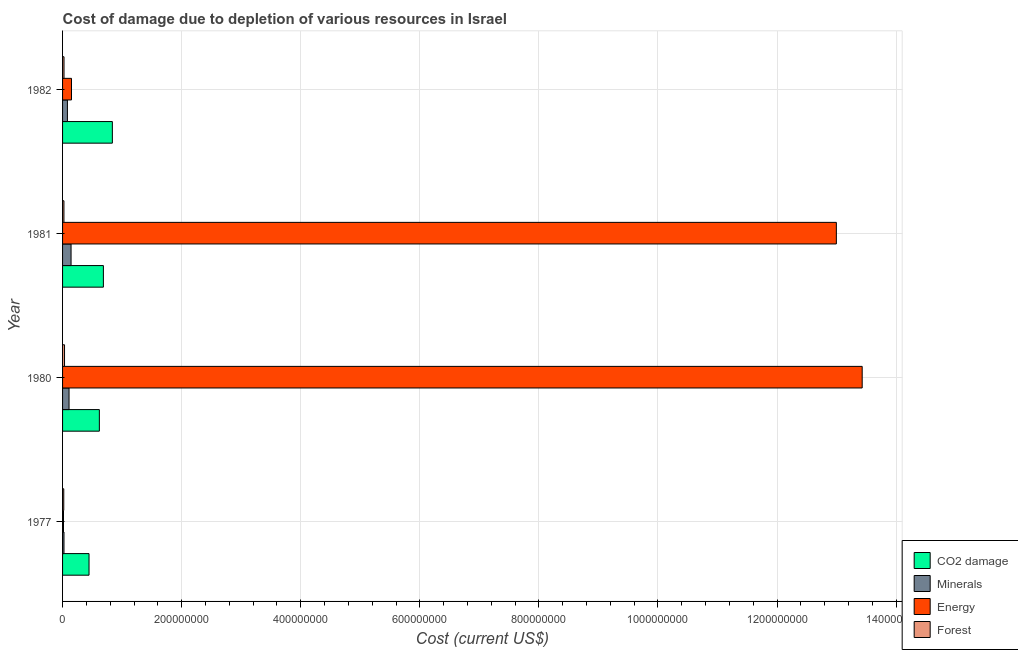Are the number of bars on each tick of the Y-axis equal?
Provide a succinct answer. Yes. How many bars are there on the 2nd tick from the top?
Your response must be concise. 4. What is the label of the 1st group of bars from the top?
Offer a very short reply. 1982. What is the cost of damage due to depletion of forests in 1981?
Your answer should be compact. 2.30e+06. Across all years, what is the maximum cost of damage due to depletion of energy?
Your answer should be compact. 1.34e+09. Across all years, what is the minimum cost of damage due to depletion of energy?
Your response must be concise. 1.57e+06. What is the total cost of damage due to depletion of energy in the graph?
Your answer should be compact. 2.66e+09. What is the difference between the cost of damage due to depletion of forests in 1977 and that in 1981?
Offer a very short reply. -3.02e+05. What is the difference between the cost of damage due to depletion of minerals in 1981 and the cost of damage due to depletion of forests in 1980?
Provide a succinct answer. 1.10e+07. What is the average cost of damage due to depletion of minerals per year?
Your answer should be very brief. 8.92e+06. In the year 1980, what is the difference between the cost of damage due to depletion of energy and cost of damage due to depletion of minerals?
Offer a terse response. 1.33e+09. In how many years, is the cost of damage due to depletion of forests greater than 1360000000 US$?
Your answer should be compact. 0. What is the ratio of the cost of damage due to depletion of forests in 1977 to that in 1982?
Keep it short and to the point. 0.82. Is the cost of damage due to depletion of forests in 1977 less than that in 1981?
Your answer should be very brief. Yes. What is the difference between the highest and the second highest cost of damage due to depletion of forests?
Offer a terse response. 8.64e+05. What is the difference between the highest and the lowest cost of damage due to depletion of forests?
Give a very brief answer. 1.29e+06. In how many years, is the cost of damage due to depletion of energy greater than the average cost of damage due to depletion of energy taken over all years?
Provide a succinct answer. 2. Is the sum of the cost of damage due to depletion of coal in 1977 and 1982 greater than the maximum cost of damage due to depletion of energy across all years?
Offer a very short reply. No. Is it the case that in every year, the sum of the cost of damage due to depletion of forests and cost of damage due to depletion of energy is greater than the sum of cost of damage due to depletion of minerals and cost of damage due to depletion of coal?
Offer a terse response. No. What does the 4th bar from the top in 1982 represents?
Your response must be concise. CO2 damage. What does the 3rd bar from the bottom in 1977 represents?
Provide a succinct answer. Energy. Is it the case that in every year, the sum of the cost of damage due to depletion of coal and cost of damage due to depletion of minerals is greater than the cost of damage due to depletion of energy?
Give a very brief answer. No. How many years are there in the graph?
Provide a short and direct response. 4. What is the difference between two consecutive major ticks on the X-axis?
Ensure brevity in your answer.  2.00e+08. Are the values on the major ticks of X-axis written in scientific E-notation?
Your answer should be very brief. No. Does the graph contain grids?
Keep it short and to the point. Yes. How are the legend labels stacked?
Your response must be concise. Vertical. What is the title of the graph?
Your response must be concise. Cost of damage due to depletion of various resources in Israel . Does "Agricultural land" appear as one of the legend labels in the graph?
Offer a very short reply. No. What is the label or title of the X-axis?
Ensure brevity in your answer.  Cost (current US$). What is the Cost (current US$) in CO2 damage in 1977?
Ensure brevity in your answer.  4.44e+07. What is the Cost (current US$) of Minerals in 1977?
Give a very brief answer. 2.37e+06. What is the Cost (current US$) in Energy in 1977?
Provide a short and direct response. 1.57e+06. What is the Cost (current US$) in Forest in 1977?
Ensure brevity in your answer.  2.00e+06. What is the Cost (current US$) in CO2 damage in 1980?
Make the answer very short. 6.18e+07. What is the Cost (current US$) in Minerals in 1980?
Offer a very short reply. 1.09e+07. What is the Cost (current US$) of Energy in 1980?
Your answer should be compact. 1.34e+09. What is the Cost (current US$) in Forest in 1980?
Ensure brevity in your answer.  3.30e+06. What is the Cost (current US$) of CO2 damage in 1981?
Make the answer very short. 6.86e+07. What is the Cost (current US$) of Minerals in 1981?
Your answer should be compact. 1.43e+07. What is the Cost (current US$) of Energy in 1981?
Make the answer very short. 1.30e+09. What is the Cost (current US$) in Forest in 1981?
Make the answer very short. 2.30e+06. What is the Cost (current US$) in CO2 damage in 1982?
Offer a very short reply. 8.36e+07. What is the Cost (current US$) of Minerals in 1982?
Provide a succinct answer. 8.15e+06. What is the Cost (current US$) in Energy in 1982?
Your answer should be very brief. 1.50e+07. What is the Cost (current US$) of Forest in 1982?
Your response must be concise. 2.43e+06. Across all years, what is the maximum Cost (current US$) of CO2 damage?
Ensure brevity in your answer.  8.36e+07. Across all years, what is the maximum Cost (current US$) of Minerals?
Offer a very short reply. 1.43e+07. Across all years, what is the maximum Cost (current US$) in Energy?
Your answer should be very brief. 1.34e+09. Across all years, what is the maximum Cost (current US$) of Forest?
Your response must be concise. 3.30e+06. Across all years, what is the minimum Cost (current US$) of CO2 damage?
Provide a succinct answer. 4.44e+07. Across all years, what is the minimum Cost (current US$) in Minerals?
Keep it short and to the point. 2.37e+06. Across all years, what is the minimum Cost (current US$) in Energy?
Your answer should be very brief. 1.57e+06. Across all years, what is the minimum Cost (current US$) of Forest?
Your response must be concise. 2.00e+06. What is the total Cost (current US$) of CO2 damage in the graph?
Ensure brevity in your answer.  2.58e+08. What is the total Cost (current US$) of Minerals in the graph?
Keep it short and to the point. 3.57e+07. What is the total Cost (current US$) of Energy in the graph?
Your response must be concise. 2.66e+09. What is the total Cost (current US$) in Forest in the graph?
Give a very brief answer. 1.00e+07. What is the difference between the Cost (current US$) in CO2 damage in 1977 and that in 1980?
Your answer should be very brief. -1.74e+07. What is the difference between the Cost (current US$) in Minerals in 1977 and that in 1980?
Keep it short and to the point. -8.52e+06. What is the difference between the Cost (current US$) of Energy in 1977 and that in 1980?
Your response must be concise. -1.34e+09. What is the difference between the Cost (current US$) in Forest in 1977 and that in 1980?
Give a very brief answer. -1.29e+06. What is the difference between the Cost (current US$) in CO2 damage in 1977 and that in 1981?
Your response must be concise. -2.41e+07. What is the difference between the Cost (current US$) in Minerals in 1977 and that in 1981?
Offer a terse response. -1.19e+07. What is the difference between the Cost (current US$) in Energy in 1977 and that in 1981?
Provide a short and direct response. -1.30e+09. What is the difference between the Cost (current US$) in Forest in 1977 and that in 1981?
Offer a terse response. -3.02e+05. What is the difference between the Cost (current US$) in CO2 damage in 1977 and that in 1982?
Offer a terse response. -3.92e+07. What is the difference between the Cost (current US$) of Minerals in 1977 and that in 1982?
Offer a very short reply. -5.78e+06. What is the difference between the Cost (current US$) in Energy in 1977 and that in 1982?
Your answer should be compact. -1.34e+07. What is the difference between the Cost (current US$) of Forest in 1977 and that in 1982?
Offer a terse response. -4.31e+05. What is the difference between the Cost (current US$) of CO2 damage in 1980 and that in 1981?
Your answer should be very brief. -6.78e+06. What is the difference between the Cost (current US$) in Minerals in 1980 and that in 1981?
Your answer should be compact. -3.38e+06. What is the difference between the Cost (current US$) in Energy in 1980 and that in 1981?
Offer a terse response. 4.34e+07. What is the difference between the Cost (current US$) in Forest in 1980 and that in 1981?
Offer a very short reply. 9.93e+05. What is the difference between the Cost (current US$) in CO2 damage in 1980 and that in 1982?
Ensure brevity in your answer.  -2.18e+07. What is the difference between the Cost (current US$) of Minerals in 1980 and that in 1982?
Provide a short and direct response. 2.74e+06. What is the difference between the Cost (current US$) of Energy in 1980 and that in 1982?
Your answer should be very brief. 1.33e+09. What is the difference between the Cost (current US$) in Forest in 1980 and that in 1982?
Offer a terse response. 8.64e+05. What is the difference between the Cost (current US$) of CO2 damage in 1981 and that in 1982?
Offer a very short reply. -1.51e+07. What is the difference between the Cost (current US$) in Minerals in 1981 and that in 1982?
Offer a very short reply. 6.13e+06. What is the difference between the Cost (current US$) in Energy in 1981 and that in 1982?
Offer a terse response. 1.28e+09. What is the difference between the Cost (current US$) in Forest in 1981 and that in 1982?
Your response must be concise. -1.29e+05. What is the difference between the Cost (current US$) in CO2 damage in 1977 and the Cost (current US$) in Minerals in 1980?
Make the answer very short. 3.35e+07. What is the difference between the Cost (current US$) of CO2 damage in 1977 and the Cost (current US$) of Energy in 1980?
Provide a succinct answer. -1.30e+09. What is the difference between the Cost (current US$) of CO2 damage in 1977 and the Cost (current US$) of Forest in 1980?
Make the answer very short. 4.11e+07. What is the difference between the Cost (current US$) in Minerals in 1977 and the Cost (current US$) in Energy in 1980?
Offer a very short reply. -1.34e+09. What is the difference between the Cost (current US$) in Minerals in 1977 and the Cost (current US$) in Forest in 1980?
Your answer should be compact. -9.28e+05. What is the difference between the Cost (current US$) of Energy in 1977 and the Cost (current US$) of Forest in 1980?
Provide a succinct answer. -1.73e+06. What is the difference between the Cost (current US$) of CO2 damage in 1977 and the Cost (current US$) of Minerals in 1981?
Your answer should be very brief. 3.02e+07. What is the difference between the Cost (current US$) of CO2 damage in 1977 and the Cost (current US$) of Energy in 1981?
Offer a very short reply. -1.26e+09. What is the difference between the Cost (current US$) in CO2 damage in 1977 and the Cost (current US$) in Forest in 1981?
Ensure brevity in your answer.  4.21e+07. What is the difference between the Cost (current US$) in Minerals in 1977 and the Cost (current US$) in Energy in 1981?
Your answer should be very brief. -1.30e+09. What is the difference between the Cost (current US$) in Minerals in 1977 and the Cost (current US$) in Forest in 1981?
Offer a terse response. 6.51e+04. What is the difference between the Cost (current US$) of Energy in 1977 and the Cost (current US$) of Forest in 1981?
Provide a succinct answer. -7.37e+05. What is the difference between the Cost (current US$) in CO2 damage in 1977 and the Cost (current US$) in Minerals in 1982?
Your answer should be very brief. 3.63e+07. What is the difference between the Cost (current US$) in CO2 damage in 1977 and the Cost (current US$) in Energy in 1982?
Provide a succinct answer. 2.94e+07. What is the difference between the Cost (current US$) of CO2 damage in 1977 and the Cost (current US$) of Forest in 1982?
Your response must be concise. 4.20e+07. What is the difference between the Cost (current US$) in Minerals in 1977 and the Cost (current US$) in Energy in 1982?
Keep it short and to the point. -1.26e+07. What is the difference between the Cost (current US$) of Minerals in 1977 and the Cost (current US$) of Forest in 1982?
Make the answer very short. -6.43e+04. What is the difference between the Cost (current US$) in Energy in 1977 and the Cost (current US$) in Forest in 1982?
Keep it short and to the point. -8.67e+05. What is the difference between the Cost (current US$) of CO2 damage in 1980 and the Cost (current US$) of Minerals in 1981?
Keep it short and to the point. 4.75e+07. What is the difference between the Cost (current US$) of CO2 damage in 1980 and the Cost (current US$) of Energy in 1981?
Your response must be concise. -1.24e+09. What is the difference between the Cost (current US$) of CO2 damage in 1980 and the Cost (current US$) of Forest in 1981?
Your answer should be compact. 5.95e+07. What is the difference between the Cost (current US$) in Minerals in 1980 and the Cost (current US$) in Energy in 1981?
Make the answer very short. -1.29e+09. What is the difference between the Cost (current US$) of Minerals in 1980 and the Cost (current US$) of Forest in 1981?
Offer a terse response. 8.58e+06. What is the difference between the Cost (current US$) in Energy in 1980 and the Cost (current US$) in Forest in 1981?
Provide a succinct answer. 1.34e+09. What is the difference between the Cost (current US$) of CO2 damage in 1980 and the Cost (current US$) of Minerals in 1982?
Your answer should be very brief. 5.36e+07. What is the difference between the Cost (current US$) of CO2 damage in 1980 and the Cost (current US$) of Energy in 1982?
Your response must be concise. 4.68e+07. What is the difference between the Cost (current US$) of CO2 damage in 1980 and the Cost (current US$) of Forest in 1982?
Provide a succinct answer. 5.94e+07. What is the difference between the Cost (current US$) of Minerals in 1980 and the Cost (current US$) of Energy in 1982?
Make the answer very short. -4.13e+06. What is the difference between the Cost (current US$) of Minerals in 1980 and the Cost (current US$) of Forest in 1982?
Offer a very short reply. 8.45e+06. What is the difference between the Cost (current US$) in Energy in 1980 and the Cost (current US$) in Forest in 1982?
Ensure brevity in your answer.  1.34e+09. What is the difference between the Cost (current US$) of CO2 damage in 1981 and the Cost (current US$) of Minerals in 1982?
Provide a succinct answer. 6.04e+07. What is the difference between the Cost (current US$) in CO2 damage in 1981 and the Cost (current US$) in Energy in 1982?
Your answer should be very brief. 5.36e+07. What is the difference between the Cost (current US$) in CO2 damage in 1981 and the Cost (current US$) in Forest in 1982?
Offer a very short reply. 6.61e+07. What is the difference between the Cost (current US$) of Minerals in 1981 and the Cost (current US$) of Energy in 1982?
Your answer should be very brief. -7.43e+05. What is the difference between the Cost (current US$) in Minerals in 1981 and the Cost (current US$) in Forest in 1982?
Provide a succinct answer. 1.18e+07. What is the difference between the Cost (current US$) in Energy in 1981 and the Cost (current US$) in Forest in 1982?
Make the answer very short. 1.30e+09. What is the average Cost (current US$) in CO2 damage per year?
Your answer should be very brief. 6.46e+07. What is the average Cost (current US$) in Minerals per year?
Provide a succinct answer. 8.92e+06. What is the average Cost (current US$) of Energy per year?
Keep it short and to the point. 6.65e+08. What is the average Cost (current US$) of Forest per year?
Your response must be concise. 2.51e+06. In the year 1977, what is the difference between the Cost (current US$) in CO2 damage and Cost (current US$) in Minerals?
Your answer should be very brief. 4.21e+07. In the year 1977, what is the difference between the Cost (current US$) of CO2 damage and Cost (current US$) of Energy?
Offer a very short reply. 4.29e+07. In the year 1977, what is the difference between the Cost (current US$) in CO2 damage and Cost (current US$) in Forest?
Make the answer very short. 4.24e+07. In the year 1977, what is the difference between the Cost (current US$) of Minerals and Cost (current US$) of Energy?
Your answer should be very brief. 8.03e+05. In the year 1977, what is the difference between the Cost (current US$) of Minerals and Cost (current US$) of Forest?
Your answer should be compact. 3.67e+05. In the year 1977, what is the difference between the Cost (current US$) of Energy and Cost (current US$) of Forest?
Provide a succinct answer. -4.36e+05. In the year 1980, what is the difference between the Cost (current US$) in CO2 damage and Cost (current US$) in Minerals?
Keep it short and to the point. 5.09e+07. In the year 1980, what is the difference between the Cost (current US$) in CO2 damage and Cost (current US$) in Energy?
Offer a terse response. -1.28e+09. In the year 1980, what is the difference between the Cost (current US$) of CO2 damage and Cost (current US$) of Forest?
Keep it short and to the point. 5.85e+07. In the year 1980, what is the difference between the Cost (current US$) of Minerals and Cost (current US$) of Energy?
Your answer should be very brief. -1.33e+09. In the year 1980, what is the difference between the Cost (current US$) of Minerals and Cost (current US$) of Forest?
Ensure brevity in your answer.  7.59e+06. In the year 1980, what is the difference between the Cost (current US$) of Energy and Cost (current US$) of Forest?
Provide a succinct answer. 1.34e+09. In the year 1981, what is the difference between the Cost (current US$) in CO2 damage and Cost (current US$) in Minerals?
Your answer should be very brief. 5.43e+07. In the year 1981, what is the difference between the Cost (current US$) in CO2 damage and Cost (current US$) in Energy?
Your response must be concise. -1.23e+09. In the year 1981, what is the difference between the Cost (current US$) of CO2 damage and Cost (current US$) of Forest?
Offer a terse response. 6.63e+07. In the year 1981, what is the difference between the Cost (current US$) in Minerals and Cost (current US$) in Energy?
Your answer should be compact. -1.29e+09. In the year 1981, what is the difference between the Cost (current US$) in Minerals and Cost (current US$) in Forest?
Your response must be concise. 1.20e+07. In the year 1981, what is the difference between the Cost (current US$) of Energy and Cost (current US$) of Forest?
Make the answer very short. 1.30e+09. In the year 1982, what is the difference between the Cost (current US$) in CO2 damage and Cost (current US$) in Minerals?
Offer a very short reply. 7.55e+07. In the year 1982, what is the difference between the Cost (current US$) in CO2 damage and Cost (current US$) in Energy?
Provide a short and direct response. 6.86e+07. In the year 1982, what is the difference between the Cost (current US$) in CO2 damage and Cost (current US$) in Forest?
Your response must be concise. 8.12e+07. In the year 1982, what is the difference between the Cost (current US$) in Minerals and Cost (current US$) in Energy?
Provide a short and direct response. -6.87e+06. In the year 1982, what is the difference between the Cost (current US$) of Minerals and Cost (current US$) of Forest?
Keep it short and to the point. 5.71e+06. In the year 1982, what is the difference between the Cost (current US$) of Energy and Cost (current US$) of Forest?
Your answer should be very brief. 1.26e+07. What is the ratio of the Cost (current US$) of CO2 damage in 1977 to that in 1980?
Your answer should be compact. 0.72. What is the ratio of the Cost (current US$) of Minerals in 1977 to that in 1980?
Offer a terse response. 0.22. What is the ratio of the Cost (current US$) in Energy in 1977 to that in 1980?
Keep it short and to the point. 0. What is the ratio of the Cost (current US$) of Forest in 1977 to that in 1980?
Provide a short and direct response. 0.61. What is the ratio of the Cost (current US$) of CO2 damage in 1977 to that in 1981?
Ensure brevity in your answer.  0.65. What is the ratio of the Cost (current US$) of Minerals in 1977 to that in 1981?
Ensure brevity in your answer.  0.17. What is the ratio of the Cost (current US$) in Energy in 1977 to that in 1981?
Provide a short and direct response. 0. What is the ratio of the Cost (current US$) in Forest in 1977 to that in 1981?
Your response must be concise. 0.87. What is the ratio of the Cost (current US$) of CO2 damage in 1977 to that in 1982?
Provide a short and direct response. 0.53. What is the ratio of the Cost (current US$) in Minerals in 1977 to that in 1982?
Ensure brevity in your answer.  0.29. What is the ratio of the Cost (current US$) in Energy in 1977 to that in 1982?
Give a very brief answer. 0.1. What is the ratio of the Cost (current US$) in Forest in 1977 to that in 1982?
Your answer should be very brief. 0.82. What is the ratio of the Cost (current US$) of CO2 damage in 1980 to that in 1981?
Make the answer very short. 0.9. What is the ratio of the Cost (current US$) in Minerals in 1980 to that in 1981?
Provide a short and direct response. 0.76. What is the ratio of the Cost (current US$) in Energy in 1980 to that in 1981?
Offer a very short reply. 1.03. What is the ratio of the Cost (current US$) in Forest in 1980 to that in 1981?
Ensure brevity in your answer.  1.43. What is the ratio of the Cost (current US$) of CO2 damage in 1980 to that in 1982?
Your answer should be very brief. 0.74. What is the ratio of the Cost (current US$) in Minerals in 1980 to that in 1982?
Your response must be concise. 1.34. What is the ratio of the Cost (current US$) in Energy in 1980 to that in 1982?
Provide a succinct answer. 89.45. What is the ratio of the Cost (current US$) of Forest in 1980 to that in 1982?
Ensure brevity in your answer.  1.35. What is the ratio of the Cost (current US$) of CO2 damage in 1981 to that in 1982?
Your answer should be compact. 0.82. What is the ratio of the Cost (current US$) in Minerals in 1981 to that in 1982?
Your answer should be very brief. 1.75. What is the ratio of the Cost (current US$) in Energy in 1981 to that in 1982?
Your answer should be compact. 86.56. What is the ratio of the Cost (current US$) of Forest in 1981 to that in 1982?
Give a very brief answer. 0.95. What is the difference between the highest and the second highest Cost (current US$) in CO2 damage?
Your response must be concise. 1.51e+07. What is the difference between the highest and the second highest Cost (current US$) in Minerals?
Your answer should be very brief. 3.38e+06. What is the difference between the highest and the second highest Cost (current US$) of Energy?
Ensure brevity in your answer.  4.34e+07. What is the difference between the highest and the second highest Cost (current US$) of Forest?
Your answer should be very brief. 8.64e+05. What is the difference between the highest and the lowest Cost (current US$) in CO2 damage?
Make the answer very short. 3.92e+07. What is the difference between the highest and the lowest Cost (current US$) of Minerals?
Give a very brief answer. 1.19e+07. What is the difference between the highest and the lowest Cost (current US$) of Energy?
Your answer should be compact. 1.34e+09. What is the difference between the highest and the lowest Cost (current US$) of Forest?
Ensure brevity in your answer.  1.29e+06. 